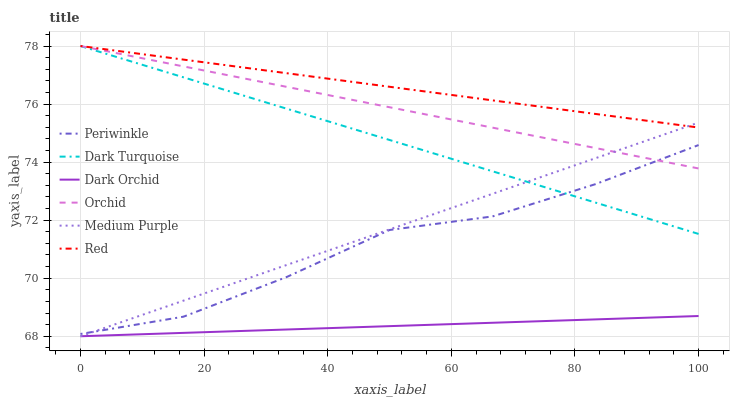Does Dark Orchid have the minimum area under the curve?
Answer yes or no. Yes. Does Red have the maximum area under the curve?
Answer yes or no. Yes. Does Medium Purple have the minimum area under the curve?
Answer yes or no. No. Does Medium Purple have the maximum area under the curve?
Answer yes or no. No. Is Orchid the smoothest?
Answer yes or no. Yes. Is Periwinkle the roughest?
Answer yes or no. Yes. Is Dark Orchid the smoothest?
Answer yes or no. No. Is Dark Orchid the roughest?
Answer yes or no. No. Does Dark Orchid have the lowest value?
Answer yes or no. Yes. Does Periwinkle have the lowest value?
Answer yes or no. No. Does Orchid have the highest value?
Answer yes or no. Yes. Does Medium Purple have the highest value?
Answer yes or no. No. Is Dark Orchid less than Red?
Answer yes or no. Yes. Is Red greater than Dark Orchid?
Answer yes or no. Yes. Does Orchid intersect Red?
Answer yes or no. Yes. Is Orchid less than Red?
Answer yes or no. No. Is Orchid greater than Red?
Answer yes or no. No. Does Dark Orchid intersect Red?
Answer yes or no. No. 